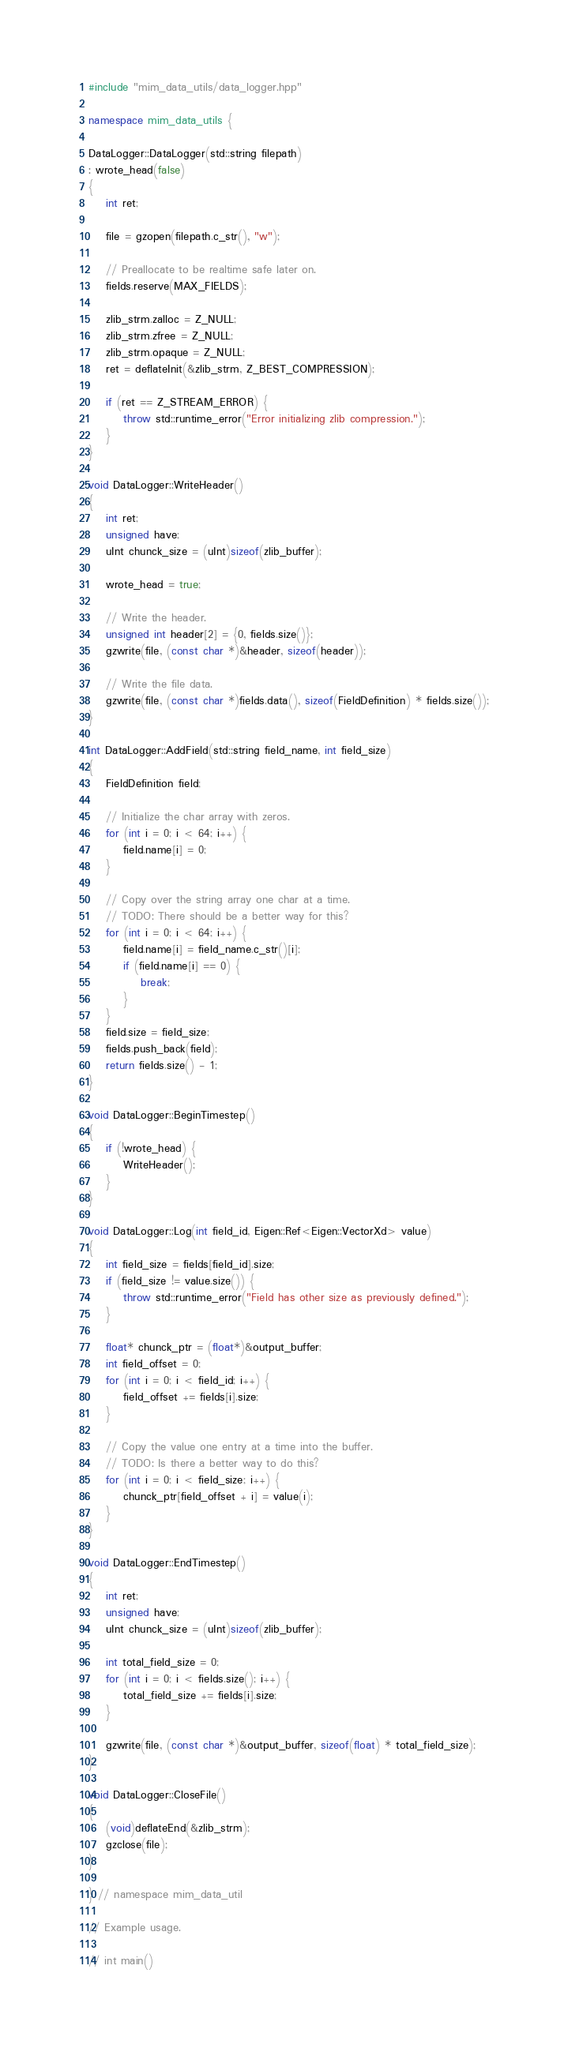<code> <loc_0><loc_0><loc_500><loc_500><_C++_>#include "mim_data_utils/data_logger.hpp"

namespace mim_data_utils {

DataLogger::DataLogger(std::string filepath)
: wrote_head(false)
{
    int ret;

    file = gzopen(filepath.c_str(), "w");

    // Preallocate to be realtime safe later on.
    fields.reserve(MAX_FIELDS);

    zlib_strm.zalloc = Z_NULL;
    zlib_strm.zfree = Z_NULL;
    zlib_strm.opaque = Z_NULL;
    ret = deflateInit(&zlib_strm, Z_BEST_COMPRESSION);

    if (ret == Z_STREAM_ERROR) {
        throw std::runtime_error("Error initializing zlib compression.");
    }
}

void DataLogger::WriteHeader()
{
    int ret;
    unsigned have;
    uInt chunck_size = (uInt)sizeof(zlib_buffer);

    wrote_head = true;

    // Write the header.
    unsigned int header[2] = {0, fields.size()};
    gzwrite(file, (const char *)&header, sizeof(header));

    // Write the file data.
    gzwrite(file, (const char *)fields.data(), sizeof(FieldDefinition) * fields.size());
}

int DataLogger::AddField(std::string field_name, int field_size)
{
    FieldDefinition field;

    // Initialize the char array with zeros.
    for (int i = 0; i < 64; i++) {
        field.name[i] = 0;
    }

    // Copy over the string array one char at a time.
    // TODO: There should be a better way for this?
    for (int i = 0; i < 64; i++) {
        field.name[i] = field_name.c_str()[i];
        if (field.name[i] == 0) {
            break;
        }
    }
    field.size = field_size;
    fields.push_back(field);
    return fields.size() - 1;
}

void DataLogger::BeginTimestep()
{
    if (!wrote_head) {
        WriteHeader();
    }
}

void DataLogger::Log(int field_id, Eigen::Ref<Eigen::VectorXd> value)
{
    int field_size = fields[field_id].size;
    if (field_size != value.size()) {
        throw std::runtime_error("Field has other size as previously defined.");
    }

    float* chunck_ptr = (float*)&output_buffer;
    int field_offset = 0;
    for (int i = 0; i < field_id; i++) {
        field_offset += fields[i].size;
    }

    // Copy the value one entry at a time into the buffer.
    // TODO: Is there a better way to do this?
    for (int i = 0; i < field_size; i++) {
        chunck_ptr[field_offset + i] = value(i);
    }
}

void DataLogger::EndTimestep()
{
    int ret;
    unsigned have;
    uInt chunck_size = (uInt)sizeof(zlib_buffer);

    int total_field_size = 0;
    for (int i = 0; i < fields.size(); i++) {
        total_field_size += fields[i].size;
    }

    gzwrite(file, (const char *)&output_buffer, sizeof(float) * total_field_size);
}

void DataLogger::CloseFile()
{
    (void)deflateEnd(&zlib_strm);
    gzclose(file);
}

} // namespace mim_data_util

// Example usage.

// int main()</code> 